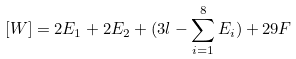<formula> <loc_0><loc_0><loc_500><loc_500>[ W ] = 2 E _ { 1 } + 2 E _ { 2 } + ( 3 l - \sum _ { i = 1 } ^ { 8 } E _ { i } ) + 2 9 F</formula> 